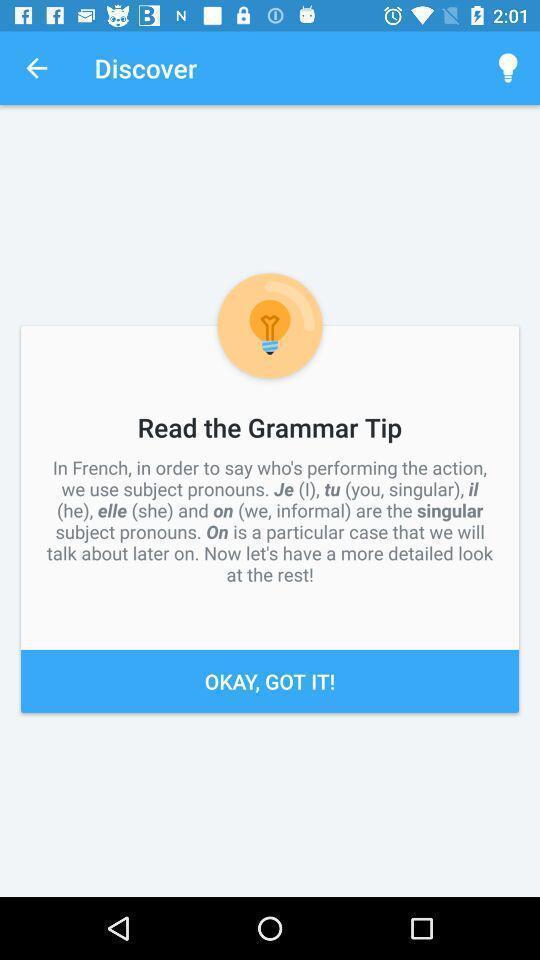Provide a description of this screenshot. Screen shows discover page in the language learning app. 